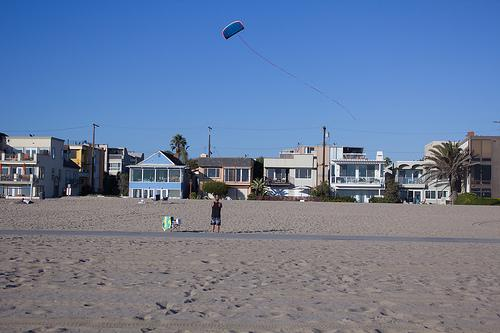Question: what is the guy doing?
Choices:
A. Swimming.
B. Running.
C. Flying a kite.
D. Dancing.
Answer with the letter. Answer: C Question: how many people are pictured?
Choices:
A. 2.
B. Just 1.
C. 3.
D. 4.
Answer with the letter. Answer: B Question: why was this photo taken?
Choices:
A. To capture a memory.
B. To show the person flying a kite.
C. To show how he swims.
D. To see the children running.
Answer with the letter. Answer: B Question: when was this photo taken?
Choices:
A. At night.
B. During the day.
C. At dawn.
D. Afternoon.
Answer with the letter. Answer: B Question: what is the background of this photo?
Choices:
A. Mountains.
B. Beaches.
C. Houses.
D. Hills.
Answer with the letter. Answer: C Question: who is flying the kite?
Choices:
A. The woman.
B. The Child.
C. The man.
D. The elderly person.
Answer with the letter. Answer: C Question: where was this photo taken?
Choices:
A. A Mountain.
B. A city.
C. A beach.
D. A Grassland.
Answer with the letter. Answer: C Question: what color is the persons shirt?
Choices:
A. Black.
B. White.
C. Blue.
D. Red.
Answer with the letter. Answer: A 